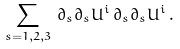<formula> <loc_0><loc_0><loc_500><loc_500>\sum _ { s = 1 , 2 , 3 } \, { \partial } _ { s } { \partial } _ { s } U ^ { i } \, { \partial } _ { s } { \partial } _ { s } U ^ { i } \, .</formula> 